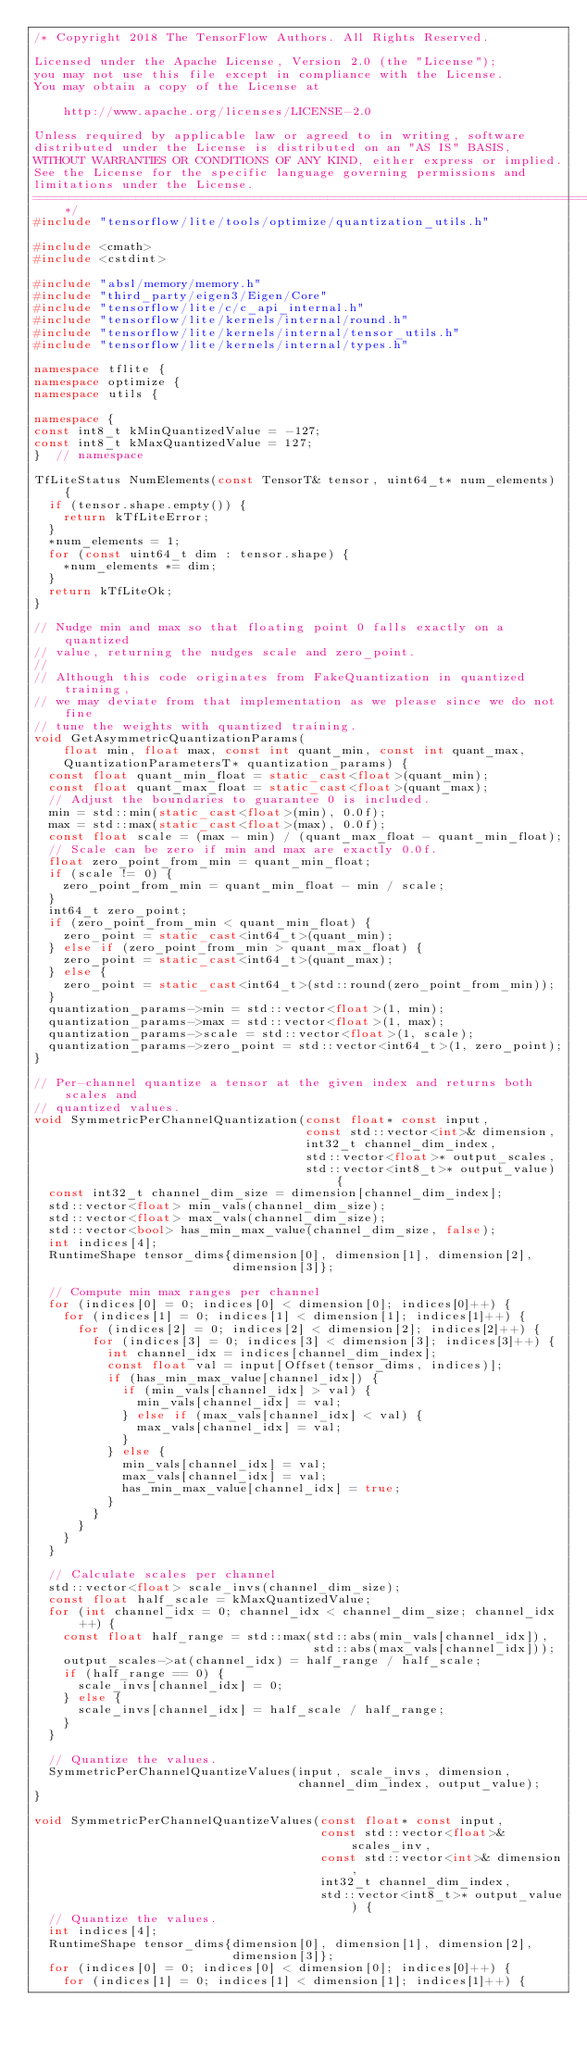<code> <loc_0><loc_0><loc_500><loc_500><_C++_>/* Copyright 2018 The TensorFlow Authors. All Rights Reserved.

Licensed under the Apache License, Version 2.0 (the "License");
you may not use this file except in compliance with the License.
You may obtain a copy of the License at

    http://www.apache.org/licenses/LICENSE-2.0

Unless required by applicable law or agreed to in writing, software
distributed under the License is distributed on an "AS IS" BASIS,
WITHOUT WARRANTIES OR CONDITIONS OF ANY KIND, either express or implied.
See the License for the specific language governing permissions and
limitations under the License.
==============================================================================*/
#include "tensorflow/lite/tools/optimize/quantization_utils.h"

#include <cmath>
#include <cstdint>

#include "absl/memory/memory.h"
#include "third_party/eigen3/Eigen/Core"
#include "tensorflow/lite/c/c_api_internal.h"
#include "tensorflow/lite/kernels/internal/round.h"
#include "tensorflow/lite/kernels/internal/tensor_utils.h"
#include "tensorflow/lite/kernels/internal/types.h"

namespace tflite {
namespace optimize {
namespace utils {

namespace {
const int8_t kMinQuantizedValue = -127;
const int8_t kMaxQuantizedValue = 127;
}  // namespace

TfLiteStatus NumElements(const TensorT& tensor, uint64_t* num_elements) {
  if (tensor.shape.empty()) {
    return kTfLiteError;
  }
  *num_elements = 1;
  for (const uint64_t dim : tensor.shape) {
    *num_elements *= dim;
  }
  return kTfLiteOk;
}

// Nudge min and max so that floating point 0 falls exactly on a quantized
// value, returning the nudges scale and zero_point.
//
// Although this code originates from FakeQuantization in quantized training,
// we may deviate from that implementation as we please since we do not fine
// tune the weights with quantized training.
void GetAsymmetricQuantizationParams(
    float min, float max, const int quant_min, const int quant_max,
    QuantizationParametersT* quantization_params) {
  const float quant_min_float = static_cast<float>(quant_min);
  const float quant_max_float = static_cast<float>(quant_max);
  // Adjust the boundaries to guarantee 0 is included.
  min = std::min(static_cast<float>(min), 0.0f);
  max = std::max(static_cast<float>(max), 0.0f);
  const float scale = (max - min) / (quant_max_float - quant_min_float);
  // Scale can be zero if min and max are exactly 0.0f.
  float zero_point_from_min = quant_min_float;
  if (scale != 0) {
    zero_point_from_min = quant_min_float - min / scale;
  }
  int64_t zero_point;
  if (zero_point_from_min < quant_min_float) {
    zero_point = static_cast<int64_t>(quant_min);
  } else if (zero_point_from_min > quant_max_float) {
    zero_point = static_cast<int64_t>(quant_max);
  } else {
    zero_point = static_cast<int64_t>(std::round(zero_point_from_min));
  }
  quantization_params->min = std::vector<float>(1, min);
  quantization_params->max = std::vector<float>(1, max);
  quantization_params->scale = std::vector<float>(1, scale);
  quantization_params->zero_point = std::vector<int64_t>(1, zero_point);
}

// Per-channel quantize a tensor at the given index and returns both scales and
// quantized values.
void SymmetricPerChannelQuantization(const float* const input,
                                     const std::vector<int>& dimension,
                                     int32_t channel_dim_index,
                                     std::vector<float>* output_scales,
                                     std::vector<int8_t>* output_value) {
  const int32_t channel_dim_size = dimension[channel_dim_index];
  std::vector<float> min_vals(channel_dim_size);
  std::vector<float> max_vals(channel_dim_size);
  std::vector<bool> has_min_max_value(channel_dim_size, false);
  int indices[4];
  RuntimeShape tensor_dims{dimension[0], dimension[1], dimension[2],
                           dimension[3]};

  // Compute min max ranges per channel
  for (indices[0] = 0; indices[0] < dimension[0]; indices[0]++) {
    for (indices[1] = 0; indices[1] < dimension[1]; indices[1]++) {
      for (indices[2] = 0; indices[2] < dimension[2]; indices[2]++) {
        for (indices[3] = 0; indices[3] < dimension[3]; indices[3]++) {
          int channel_idx = indices[channel_dim_index];
          const float val = input[Offset(tensor_dims, indices)];
          if (has_min_max_value[channel_idx]) {
            if (min_vals[channel_idx] > val) {
              min_vals[channel_idx] = val;
            } else if (max_vals[channel_idx] < val) {
              max_vals[channel_idx] = val;
            }
          } else {
            min_vals[channel_idx] = val;
            max_vals[channel_idx] = val;
            has_min_max_value[channel_idx] = true;
          }
        }
      }
    }
  }

  // Calculate scales per channel
  std::vector<float> scale_invs(channel_dim_size);
  const float half_scale = kMaxQuantizedValue;
  for (int channel_idx = 0; channel_idx < channel_dim_size; channel_idx++) {
    const float half_range = std::max(std::abs(min_vals[channel_idx]),
                                      std::abs(max_vals[channel_idx]));
    output_scales->at(channel_idx) = half_range / half_scale;
    if (half_range == 0) {
      scale_invs[channel_idx] = 0;
    } else {
      scale_invs[channel_idx] = half_scale / half_range;
    }
  }

  // Quantize the values.
  SymmetricPerChannelQuantizeValues(input, scale_invs, dimension,
                                    channel_dim_index, output_value);
}

void SymmetricPerChannelQuantizeValues(const float* const input,
                                       const std::vector<float>& scales_inv,
                                       const std::vector<int>& dimension,
                                       int32_t channel_dim_index,
                                       std::vector<int8_t>* output_value) {
  // Quantize the values.
  int indices[4];
  RuntimeShape tensor_dims{dimension[0], dimension[1], dimension[2],
                           dimension[3]};
  for (indices[0] = 0; indices[0] < dimension[0]; indices[0]++) {
    for (indices[1] = 0; indices[1] < dimension[1]; indices[1]++) {</code> 